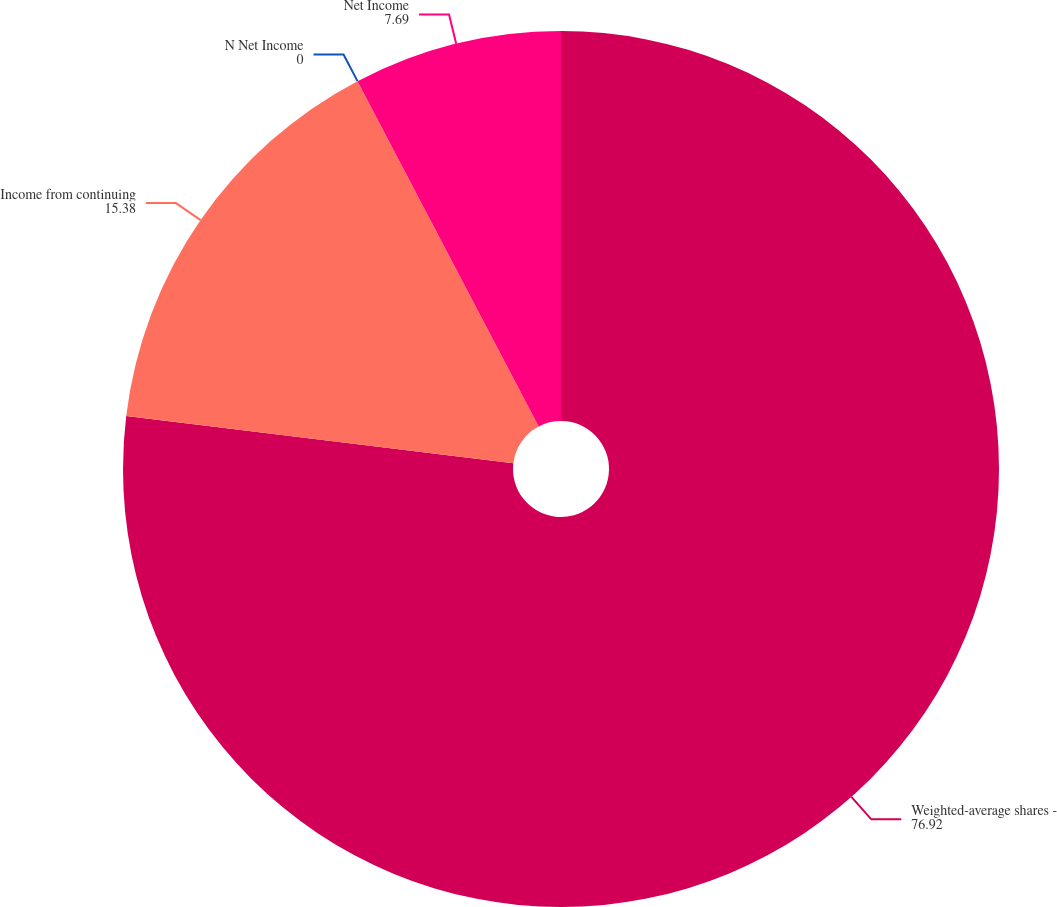<chart> <loc_0><loc_0><loc_500><loc_500><pie_chart><fcel>Weighted-average shares -<fcel>Income from continuing<fcel>N Net Income<fcel>Net Income<nl><fcel>76.92%<fcel>15.38%<fcel>0.0%<fcel>7.69%<nl></chart> 